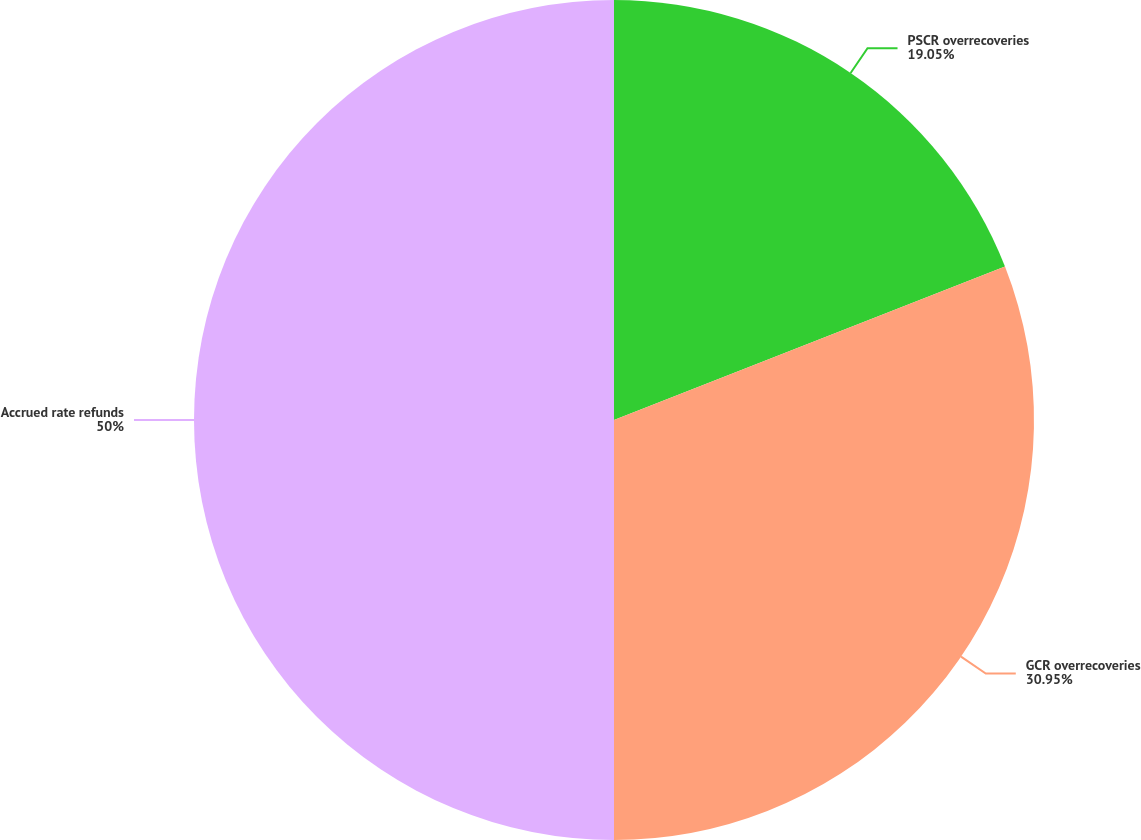Convert chart. <chart><loc_0><loc_0><loc_500><loc_500><pie_chart><fcel>PSCR overrecoveries<fcel>GCR overrecoveries<fcel>Accrued rate refunds<nl><fcel>19.05%<fcel>30.95%<fcel>50.0%<nl></chart> 